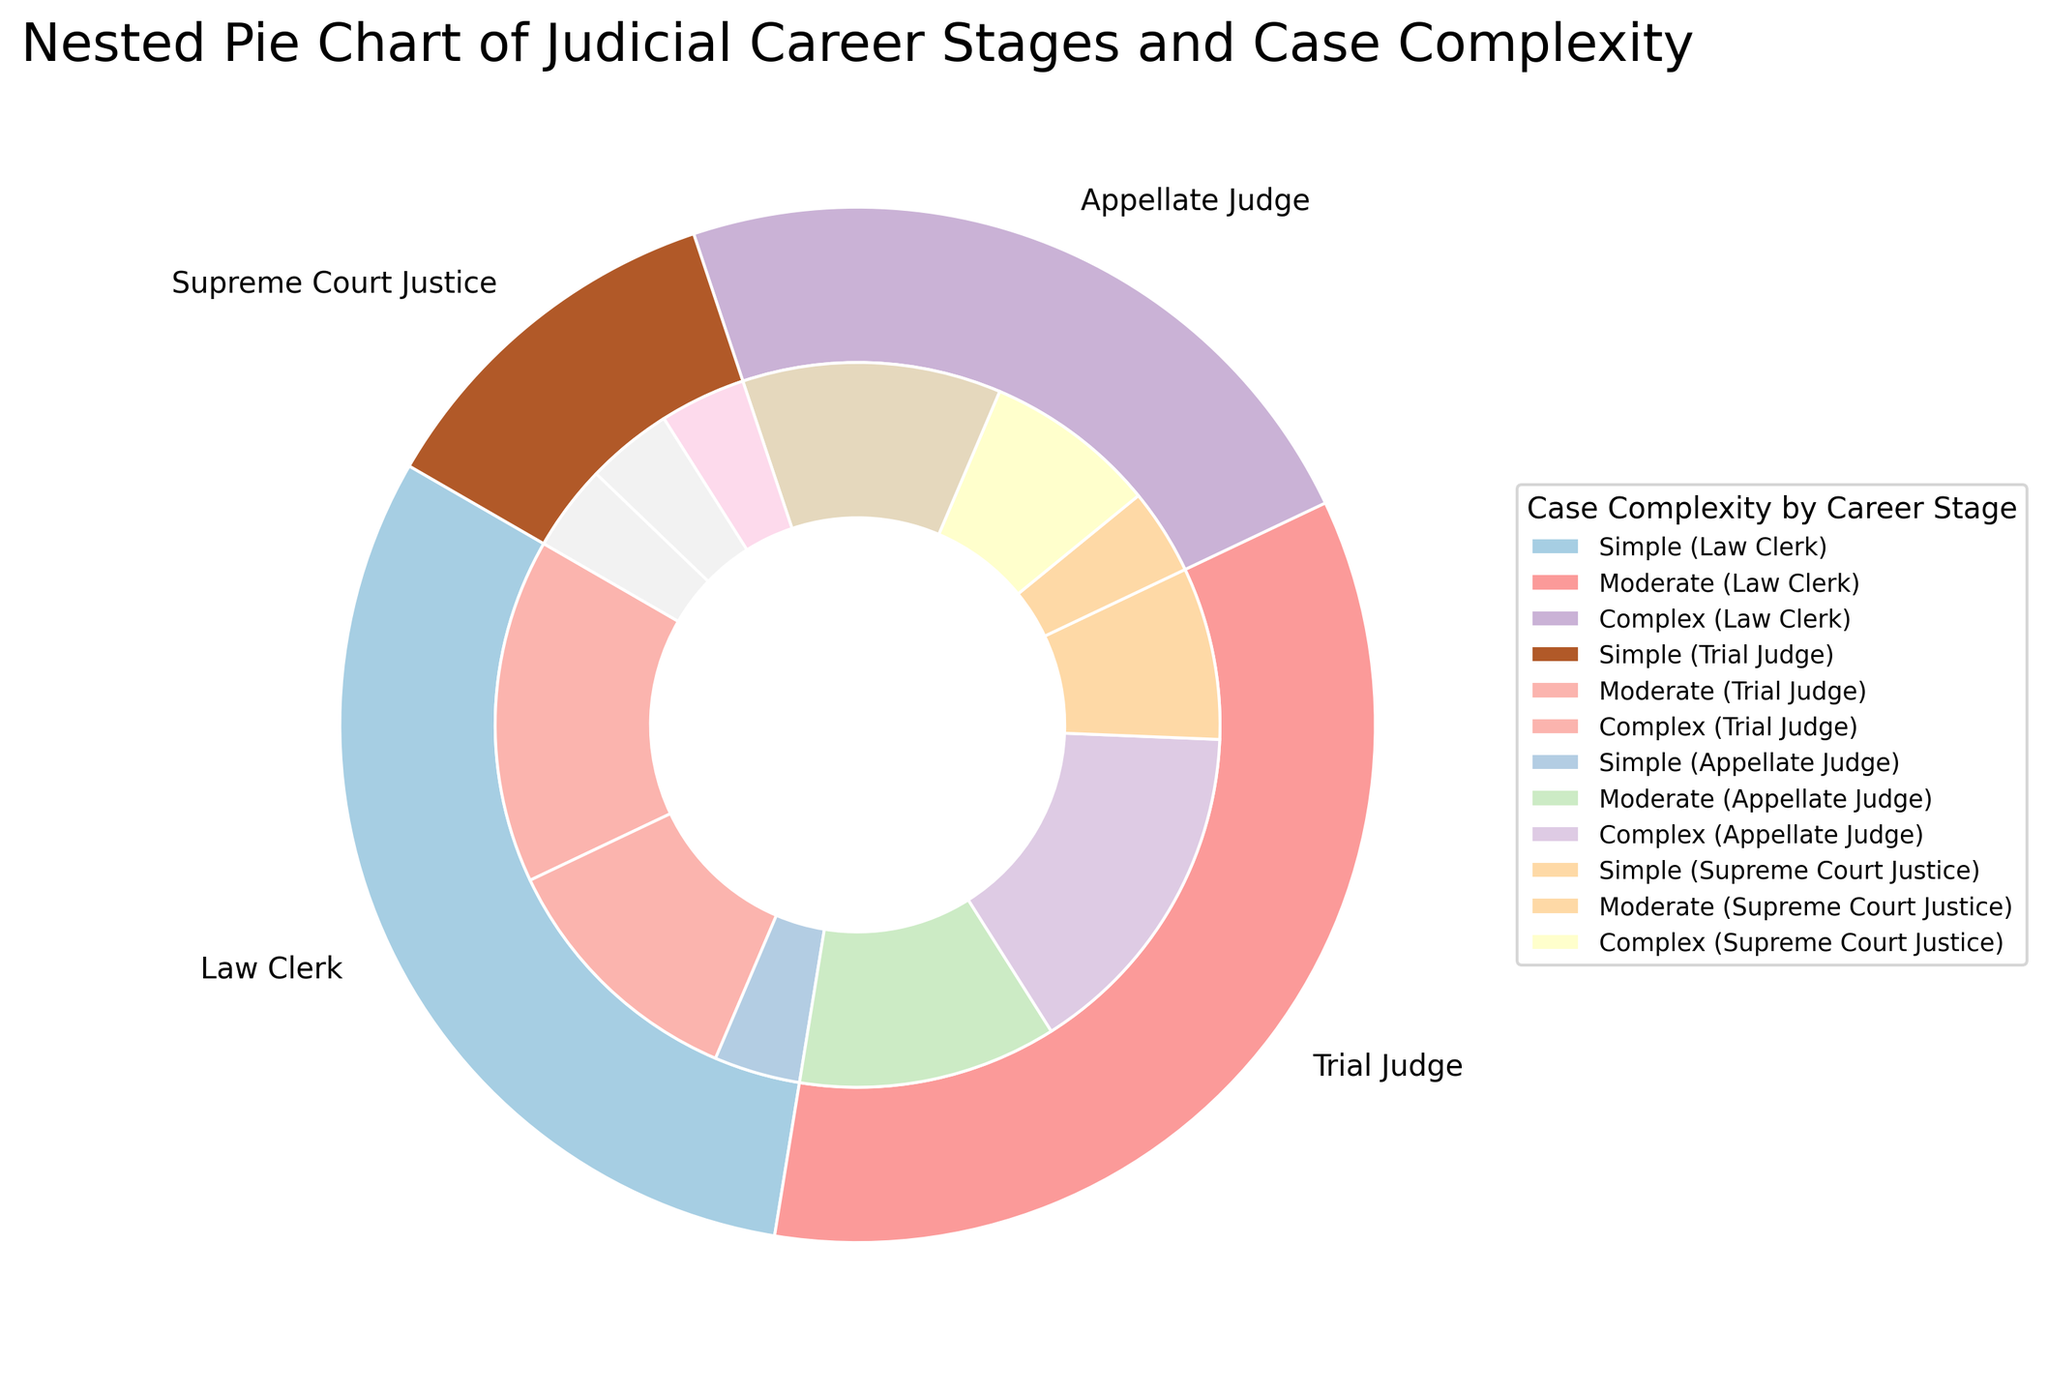what is the total percentage of simple cases across all Judicial Career Stages? Simple cases for Law Clerk (20) + Trial Judge (15) + Appellate Judge (5) + Supreme Court Justice (5) sum up to 20+15+5+5 = 45%
Answer: 45% Which Judicial Career Stage handles the highest percentage of complex cases? The complex case percentages are 5% for Law Clerk, 10% for Trial Judge, 15% for Appellate Judge, and 5% for Supreme Court Justice. Appellate Judge has the highest with 15%.
Answer: Appellate Judge What is the difference in the percentage of moderate cases between Trial Judges and Supreme Court Justices? Moderate cases for Trial Judges (20%) - Moderate cases for Supreme Court Justices (5%) = 20% - 5% = 15%
Answer: 15% What proportion of the total percentage of cases does the Law Clerk stage represent? The percentage sizes for Law Clerk (20 + 15 + 5) sum up to 40%. The total percentages are 100%, so Law Clerk represents 40%.
Answer: 40% How many Judicial Career Stages have the same percentage for complex cases? Appellate Judge (15%), Trial Judge (10%), Law Clerk (5%), Supreme Court Justice (5%). Two stages (Law Clerk and Supreme Court Justice) have the same percentage for complex cases, 5%.
Answer: Two What colors represent the Trial Judge stage and the complex case level in the figure? The Trial Judge color would be one from the paired colormap, and the complex case level color would be from the pastel1 colormap. These colors are designed to be distinct but meaningful.
Answer: Paired & Pastel1 Compare the percentage of moderate cases across different Judicial Career Stages. Which stages have a higher percentage of moderate cases than simple cases? Moderate cases: Law Clerk (15%), Trial Judge (20%), Appellate Judge (10%), Supreme Court Justice (5%). Compare with simple cases: Law Clerk (20%), Trial Judge (15%), Appellate Judge (5%), Supreme Court Justice (5%). Only the Trial Judge stage has a higher percentage of moderate (20%) than simple cases (15%).
Answer: Trial Judge 